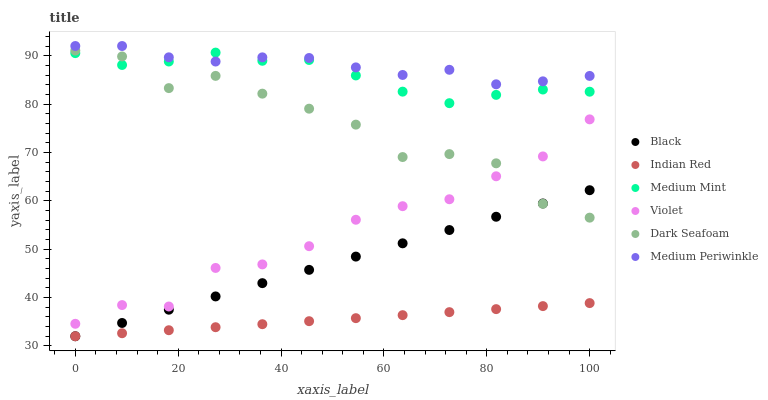Does Indian Red have the minimum area under the curve?
Answer yes or no. Yes. Does Medium Periwinkle have the maximum area under the curve?
Answer yes or no. Yes. Does Dark Seafoam have the minimum area under the curve?
Answer yes or no. No. Does Dark Seafoam have the maximum area under the curve?
Answer yes or no. No. Is Black the smoothest?
Answer yes or no. Yes. Is Dark Seafoam the roughest?
Answer yes or no. Yes. Is Medium Periwinkle the smoothest?
Answer yes or no. No. Is Medium Periwinkle the roughest?
Answer yes or no. No. Does Black have the lowest value?
Answer yes or no. Yes. Does Dark Seafoam have the lowest value?
Answer yes or no. No. Does Medium Periwinkle have the highest value?
Answer yes or no. Yes. Does Dark Seafoam have the highest value?
Answer yes or no. No. Is Indian Red less than Dark Seafoam?
Answer yes or no. Yes. Is Medium Periwinkle greater than Indian Red?
Answer yes or no. Yes. Does Indian Red intersect Black?
Answer yes or no. Yes. Is Indian Red less than Black?
Answer yes or no. No. Is Indian Red greater than Black?
Answer yes or no. No. Does Indian Red intersect Dark Seafoam?
Answer yes or no. No. 